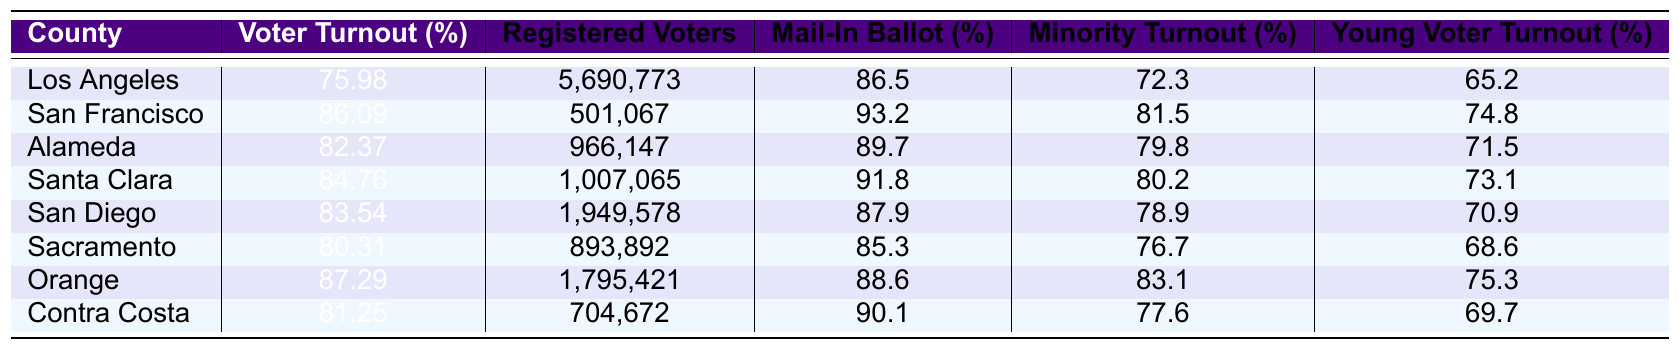What is the voter turnout percentage for Orange County? The table shows the voter turnout for Orange County as 87.29%.
Answer: 87.29% Which county has the highest registered voters? Los Angeles has the highest number of registered voters at 5,690,773.
Answer: Los Angeles What is the average voter turnout across all listed counties? Adding up the voter turnout percentages (75.98 + 86.09 + 82.37 + 84.76 + 83.54 + 80.31 + 87.29 + 81.25) equals 570.59. Dividing this by 8 (number of counties) gives an average of 71.32%.
Answer: 81.32% Does San Francisco have a higher mail-in ballot percentage than Sacramento? San Francisco has a mail-in ballot percentage of 93.2%, while Sacramento has 85.3%. Since 93.2% is greater than 85.3%.
Answer: Yes Which county has the lowest young voter turnout? Comparing the young voter turnout percentages, Sacramento has the lowest at 68.6%.
Answer: Sacramento What is the difference in voter turnout rates between Alameda and Santa Clara? The difference is calculated by subtracting Alameda's voter turnout (82.37%) from Santa Clara's (84.76%), which is 84.76 - 82.37 = 2.39%.
Answer: 2.39% Which county shows the lowest minority voter turnout? Looking at the minority voter turnout rates, Los Angeles shows the lowest at 72.3%.
Answer: Los Angeles How many registered voters are there in Contra Costa County? The table lists 704,672 registered voters for Contra Costa County.
Answer: 704,672 Compare the mail-in ballot percentages for San Diego and Santa Clara counties. San Diego has a mail-in ballot percentage of 87.9% and Santa Clara has 91.8%. Since 91.8% is greater than 87.9%, Santa Clara has a higher mail-in ballot percentage.
Answer: Santa Clara What is the total number of registered voters across all counties listed? Adding the registered voters (5690773 + 501067 + 966147 + 1007065 + 1949578 + 893892 + 1795421 + 704672) results in a total of 11145703 registered voters.
Answer: 11,145,703 